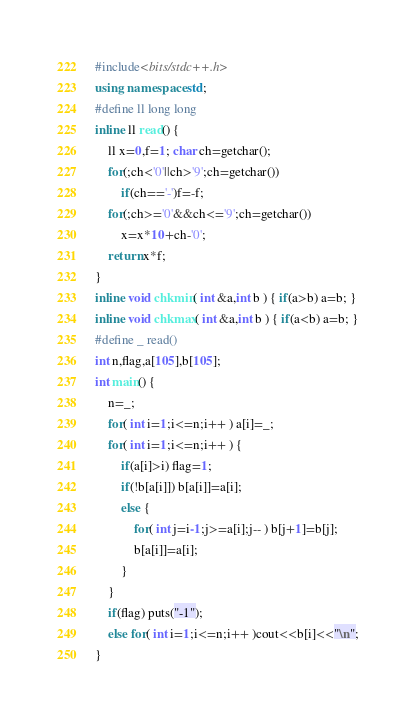Convert code to text. <code><loc_0><loc_0><loc_500><loc_500><_C++_>#include<bits/stdc++.h>
using namespace std;
#define ll long long
inline ll read() {
    ll x=0,f=1; char ch=getchar();
    for(;ch<'0'||ch>'9';ch=getchar())
        if(ch=='-')f=-f;
    for(;ch>='0'&&ch<='9';ch=getchar())
        x=x*10+ch-'0';
    return x*f;
}
inline void chkmin( int &a,int b ) { if(a>b) a=b; }
inline void chkmax( int &a,int b ) { if(a<b) a=b; }
#define _ read()
int n,flag,a[105],b[105];
int main() {
	n=_;
	for( int i=1;i<=n;i++ ) a[i]=_;
	for( int i=1;i<=n;i++ ) {
		if(a[i]>i) flag=1;
		if(!b[a[i]]) b[a[i]]=a[i];
		else {
			for( int j=i-1;j>=a[i];j-- ) b[j+1]=b[j];
			b[a[i]]=a[i];
		}
	}
	if(flag) puts("-1");
	else for( int i=1;i<=n;i++ )cout<<b[i]<<"\n";
}</code> 